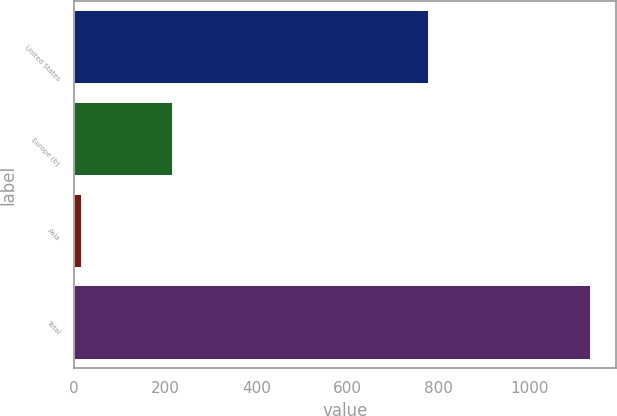Convert chart to OTSL. <chart><loc_0><loc_0><loc_500><loc_500><bar_chart><fcel>United States<fcel>Europe (b)<fcel>Asia<fcel>Total<nl><fcel>776<fcel>216<fcel>15<fcel>1132<nl></chart> 